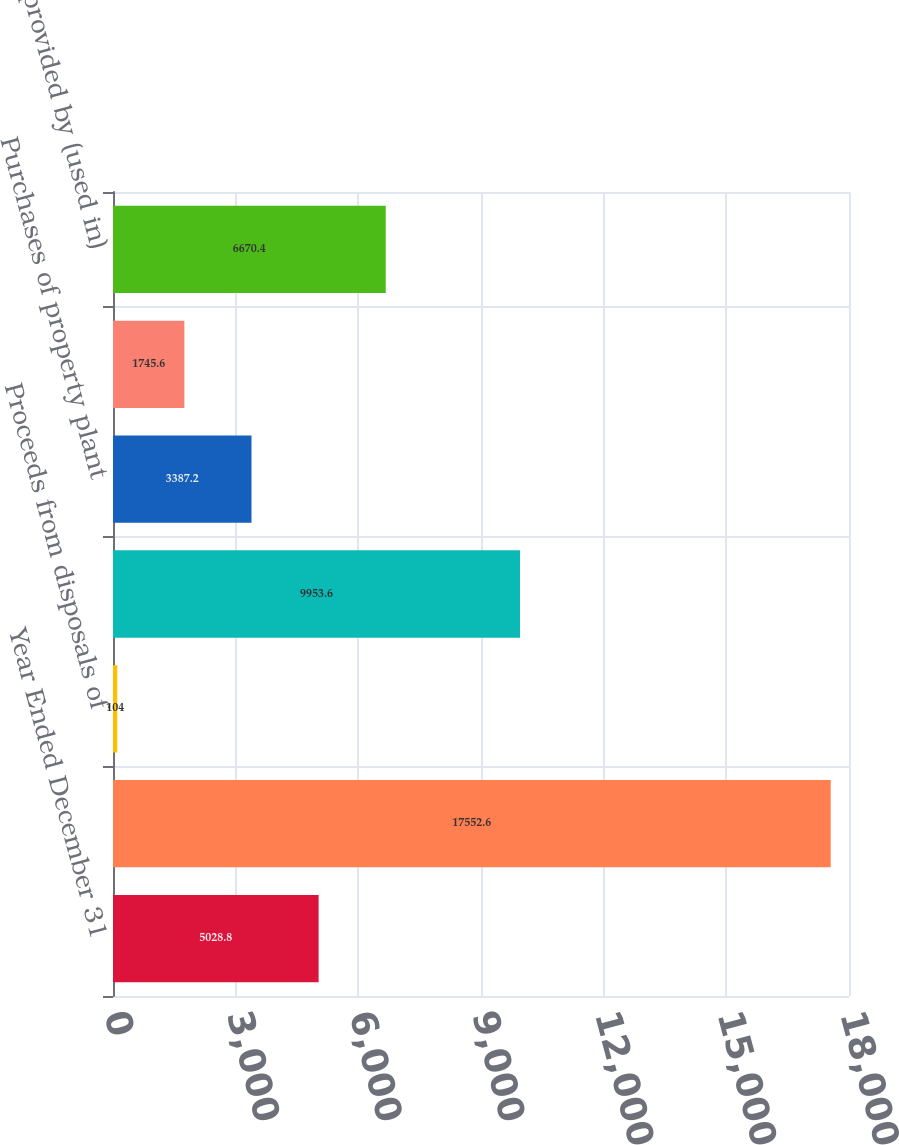<chart> <loc_0><loc_0><loc_500><loc_500><bar_chart><fcel>Year Ended December 31<fcel>Purchases of investments<fcel>Proceeds from disposals of<fcel>Acquisitions of businesses<fcel>Purchases of property plant<fcel>Other investing activities<fcel>Net cash provided by (used in)<nl><fcel>5028.8<fcel>17552.6<fcel>104<fcel>9953.6<fcel>3387.2<fcel>1745.6<fcel>6670.4<nl></chart> 